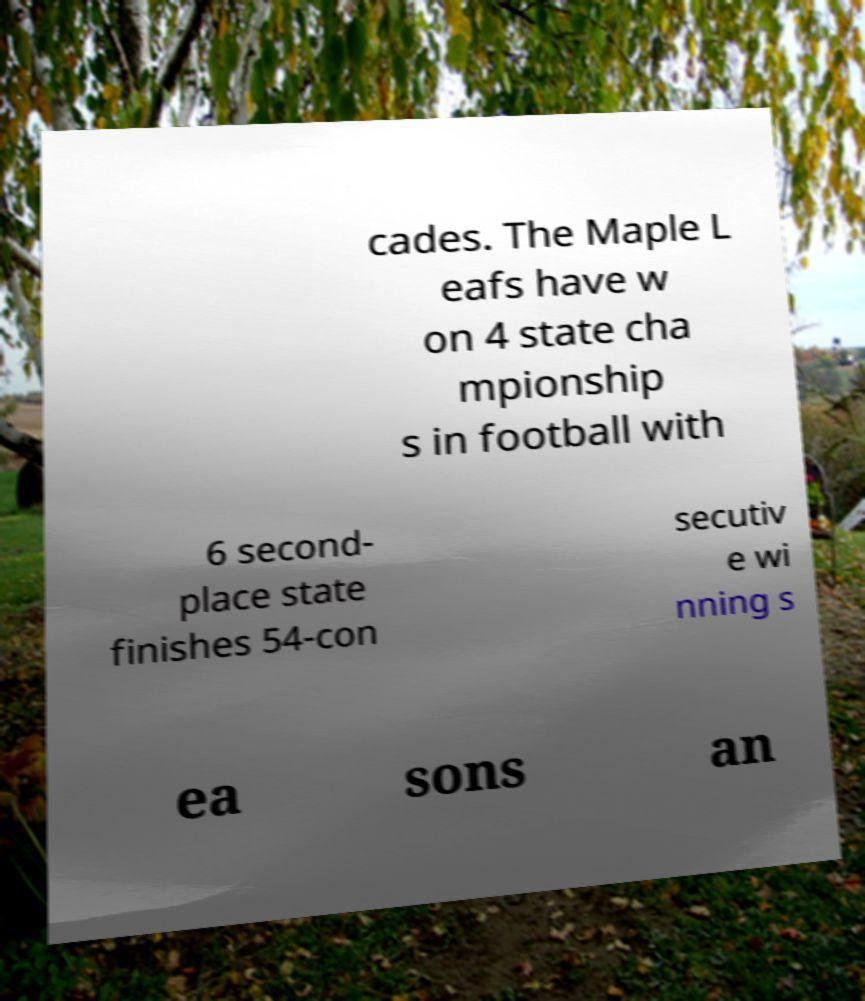Can you read and provide the text displayed in the image?This photo seems to have some interesting text. Can you extract and type it out for me? cades. The Maple L eafs have w on 4 state cha mpionship s in football with 6 second- place state finishes 54-con secutiv e wi nning s ea sons an 